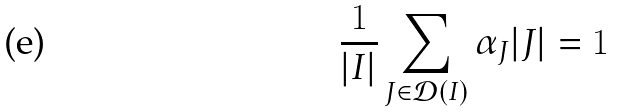Convert formula to latex. <formula><loc_0><loc_0><loc_500><loc_500>\frac { 1 } { | I | } \sum _ { J \in \mathcal { D } ( I ) } \alpha _ { J } | J | = 1</formula> 